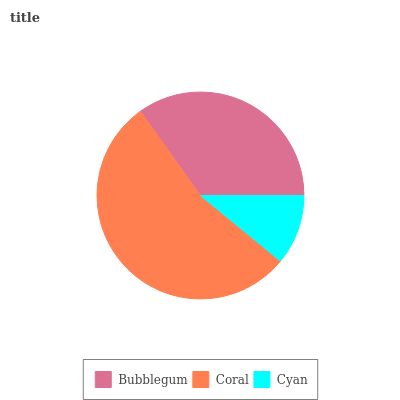Is Cyan the minimum?
Answer yes or no. Yes. Is Coral the maximum?
Answer yes or no. Yes. Is Coral the minimum?
Answer yes or no. No. Is Cyan the maximum?
Answer yes or no. No. Is Coral greater than Cyan?
Answer yes or no. Yes. Is Cyan less than Coral?
Answer yes or no. Yes. Is Cyan greater than Coral?
Answer yes or no. No. Is Coral less than Cyan?
Answer yes or no. No. Is Bubblegum the high median?
Answer yes or no. Yes. Is Bubblegum the low median?
Answer yes or no. Yes. Is Cyan the high median?
Answer yes or no. No. Is Cyan the low median?
Answer yes or no. No. 